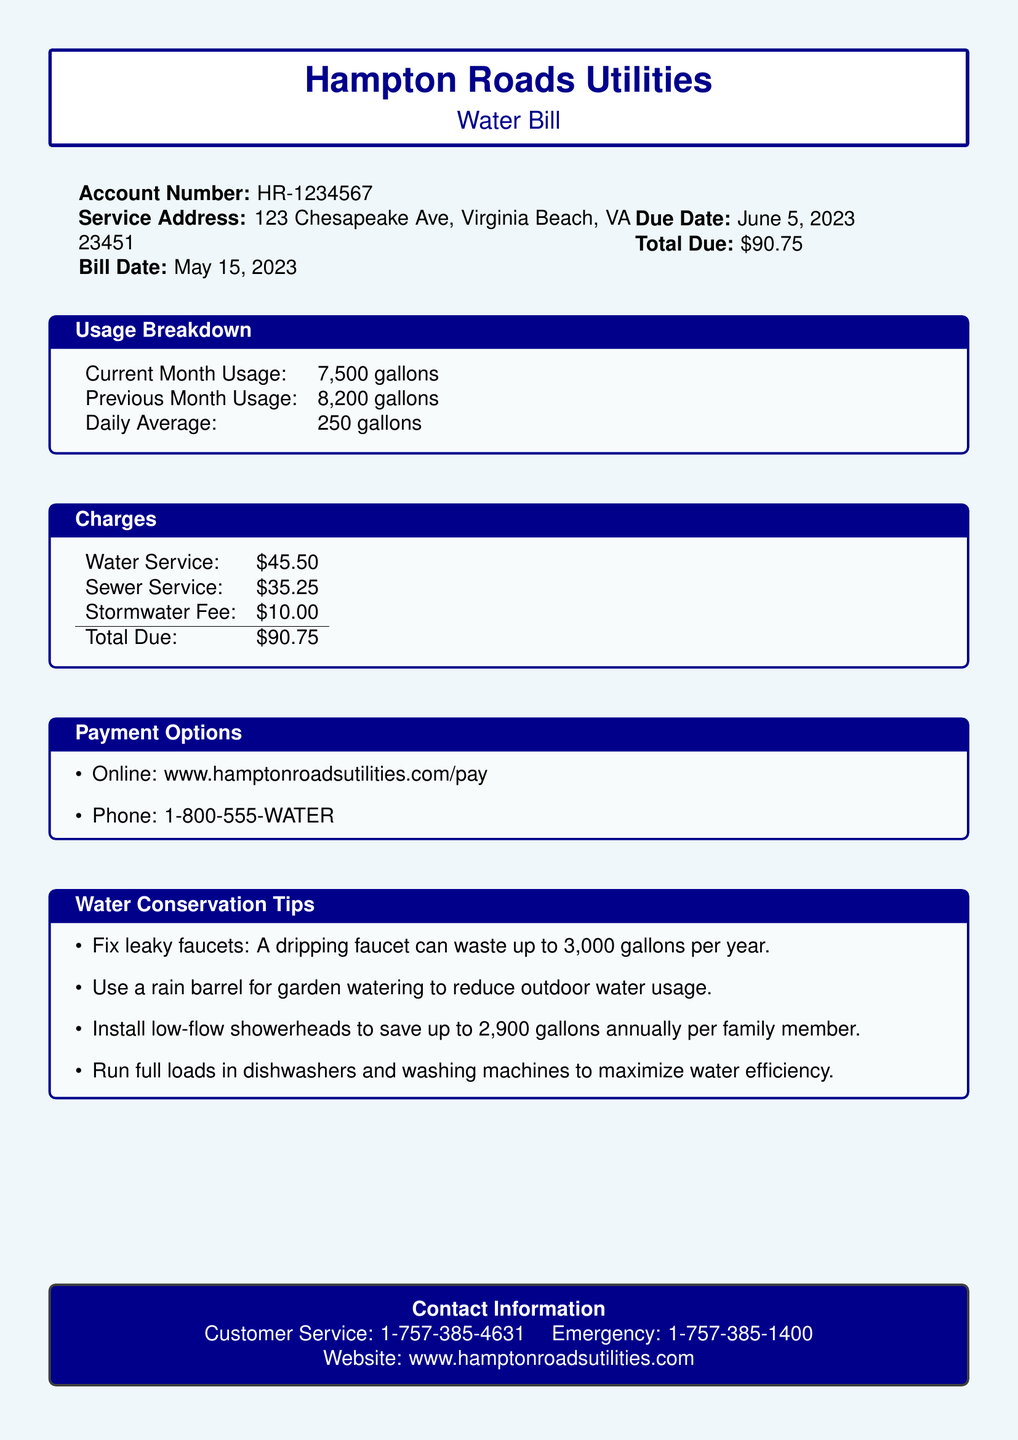What is the account number? The account number is listed under the account details section of the document.
Answer: HR-1234567 What is the total due amount? The total due amount can be found at the end of the charges section.
Answer: $90.75 What was the previous month's usage? The previous month's usage is mentioned in the usage breakdown section.
Answer: 8,200 gallons What is the daily average water usage? The daily average is specifically stated in the usage breakdown.
Answer: 250 gallons What is the sewer service charge? The sewer service charge is detailed in the charges section of the bill.
Answer: $35.25 How much can a family save by installing low-flow showerheads? This information is provided in the water conservation tips listed in the document.
Answer: 2,900 gallons annually per family member What is one payment option available? Payment options are listed at the end of the document specifying how payments can be made.
Answer: Online What is the service address? The service address is displayed in the account details section.
Answer: 123 Chesapeake Ave, Virginia Beach, VA 23451 What is the due date for this water bill? The due date can be found near the account details in the document.
Answer: June 5, 2023 